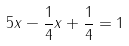Convert formula to latex. <formula><loc_0><loc_0><loc_500><loc_500>5 x - \frac { 1 } { 4 } x + \frac { 1 } { 4 } = 1</formula> 